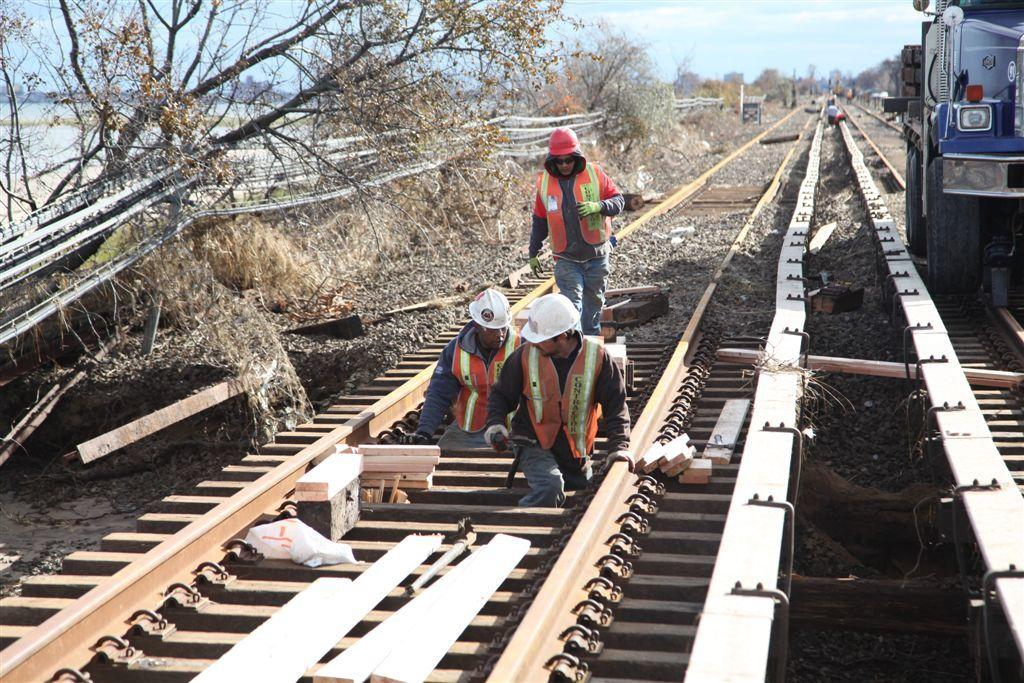What is the person in the image doing? There is a person walking in the image. What protective gear is the person wearing? The person is wearing gloves and a helmet. How many people are on the track in the image? There are two people on the track in the image. What else is on the track besides the people? There is a vehicle on the track. What type of natural scenery can be seen in the image? Trees are visible in the image. What is visible in the background of the image? There is a sky visible in the background. What type of lettuce is being used as a weapon in the image? There is no lettuce or weapon present in the image; it features a person walking on a track with a vehicle and trees in the background. 